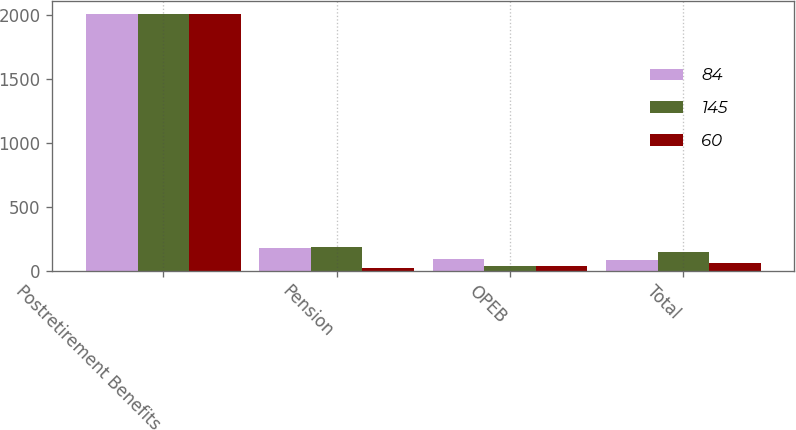Convert chart to OTSL. <chart><loc_0><loc_0><loc_500><loc_500><stacked_bar_chart><ecel><fcel>Postretirement Benefits<fcel>Pension<fcel>OPEB<fcel>Total<nl><fcel>84<fcel>2010<fcel>174<fcel>90<fcel>84<nl><fcel>145<fcel>2009<fcel>185<fcel>40<fcel>145<nl><fcel>60<fcel>2008<fcel>23<fcel>37<fcel>60<nl></chart> 